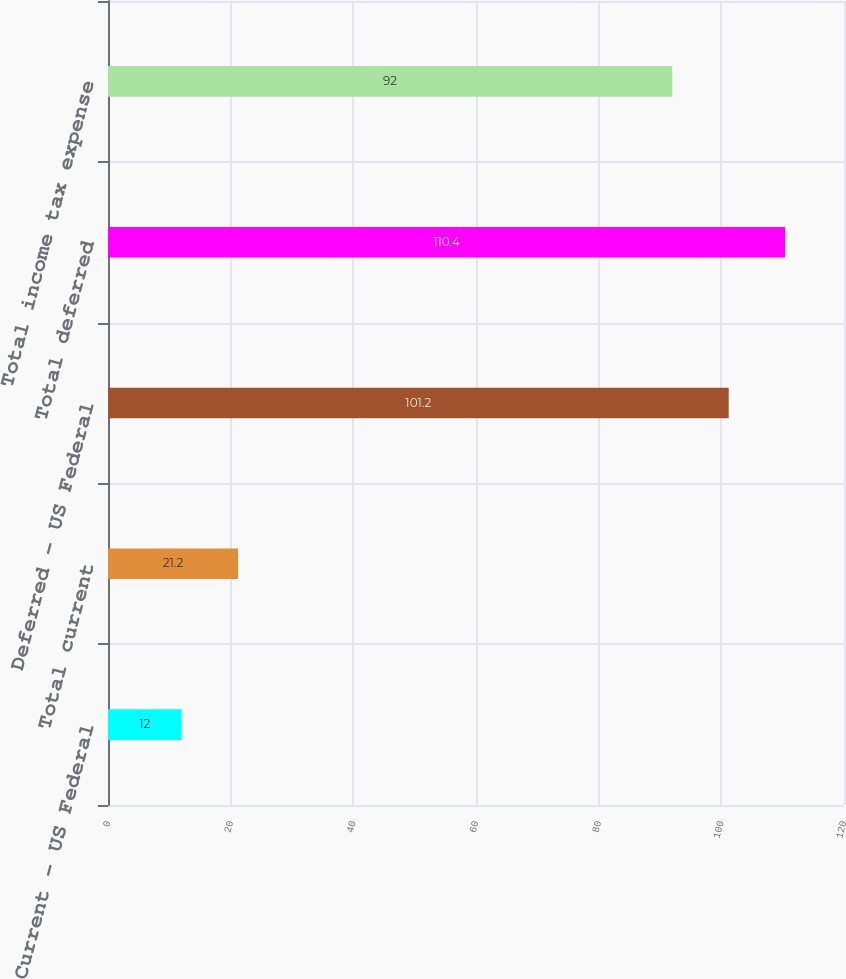Convert chart to OTSL. <chart><loc_0><loc_0><loc_500><loc_500><bar_chart><fcel>Current - US Federal<fcel>Total current<fcel>Deferred - US Federal<fcel>Total deferred<fcel>Total income tax expense<nl><fcel>12<fcel>21.2<fcel>101.2<fcel>110.4<fcel>92<nl></chart> 